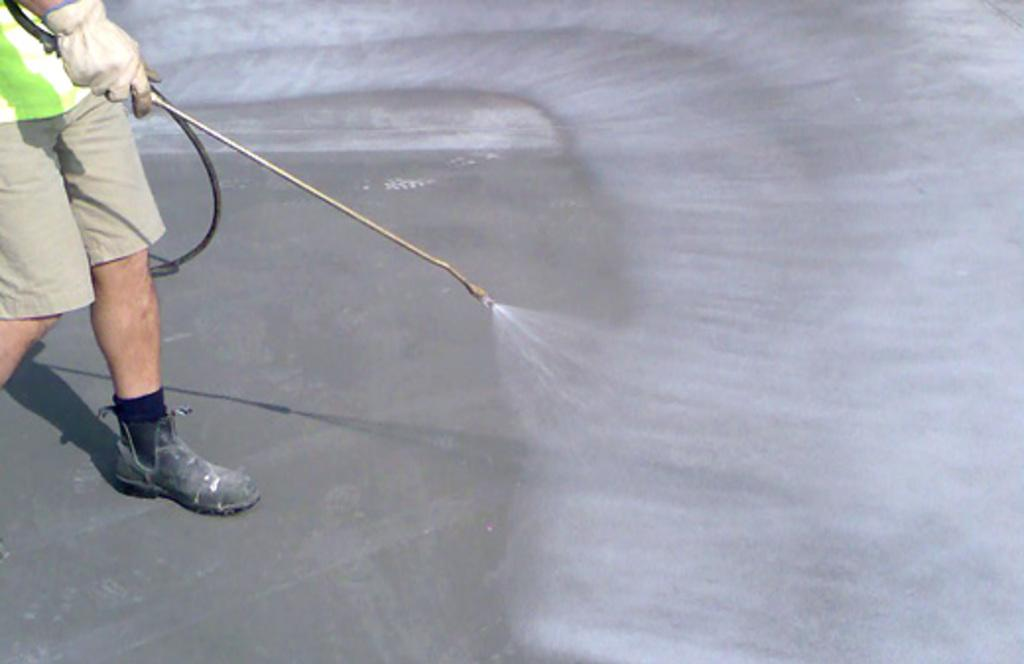What is the main subject of the image? There is a person in the image. What is the person doing in the image? The person is performing an action that involves catching and spraying, but the specific object is not clear. What type of calculator is the person using to catch and spray in the image? There is no calculator present in the image, and the person is not using any calculator for catching and spraying. 